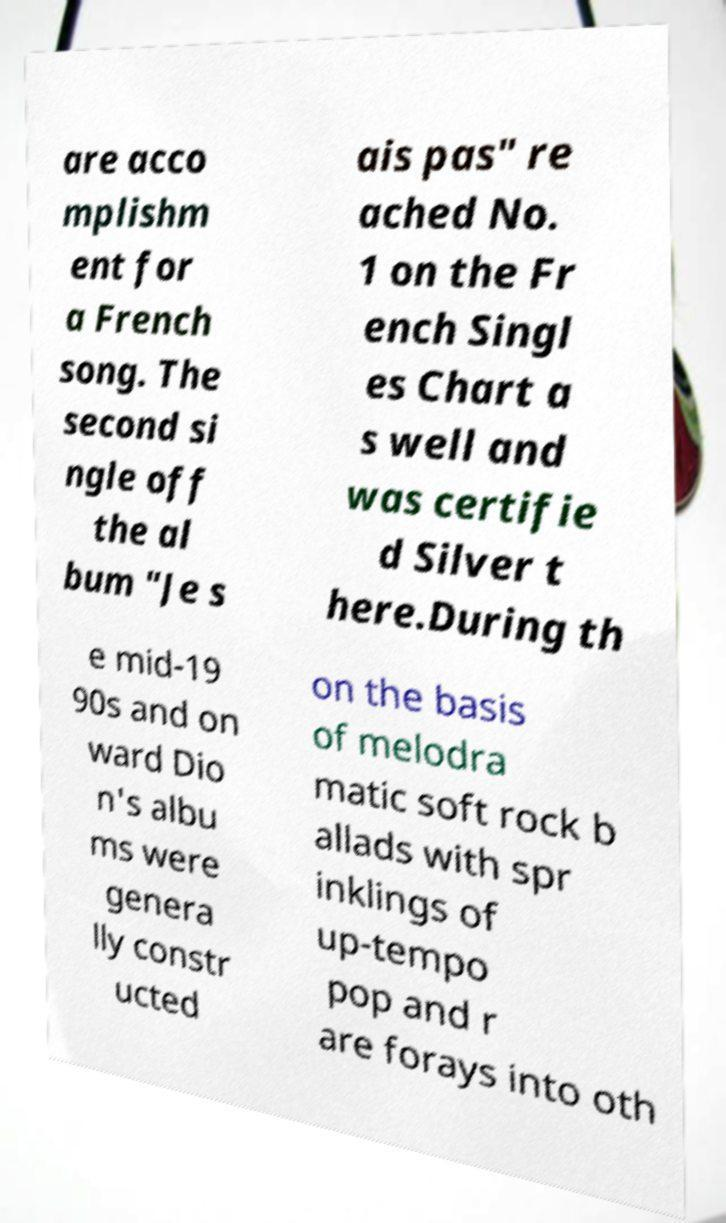What messages or text are displayed in this image? I need them in a readable, typed format. are acco mplishm ent for a French song. The second si ngle off the al bum "Je s ais pas" re ached No. 1 on the Fr ench Singl es Chart a s well and was certifie d Silver t here.During th e mid-19 90s and on ward Dio n's albu ms were genera lly constr ucted on the basis of melodra matic soft rock b allads with spr inklings of up-tempo pop and r are forays into oth 